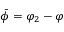Convert formula to latex. <formula><loc_0><loc_0><loc_500><loc_500>\bar { \phi } = \varphi _ { 2 } - \varphi</formula> 